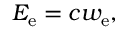<formula> <loc_0><loc_0><loc_500><loc_500>E _ { e } = c w _ { e } ,</formula> 